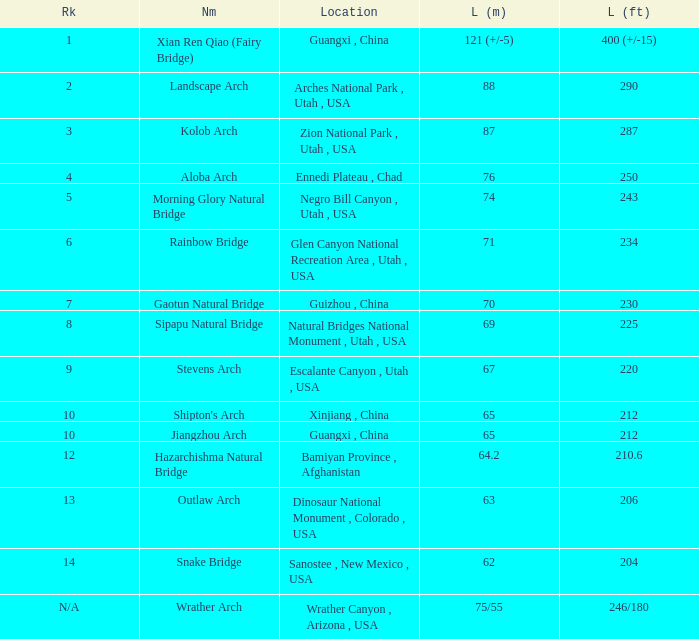Where is the longest arch with a length in meters of 64.2? Bamiyan Province , Afghanistan. 